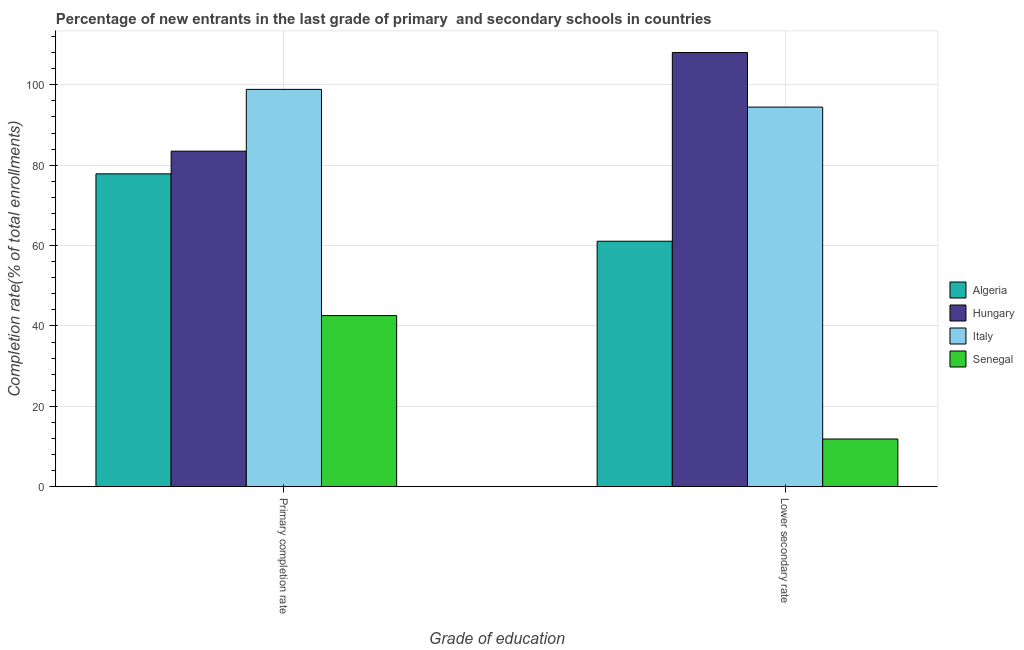How many different coloured bars are there?
Ensure brevity in your answer.  4. Are the number of bars per tick equal to the number of legend labels?
Provide a short and direct response. Yes. What is the label of the 2nd group of bars from the left?
Offer a terse response. Lower secondary rate. What is the completion rate in primary schools in Senegal?
Your response must be concise. 42.58. Across all countries, what is the maximum completion rate in secondary schools?
Your answer should be compact. 108.03. Across all countries, what is the minimum completion rate in primary schools?
Offer a terse response. 42.58. In which country was the completion rate in secondary schools maximum?
Your answer should be very brief. Hungary. In which country was the completion rate in secondary schools minimum?
Your response must be concise. Senegal. What is the total completion rate in primary schools in the graph?
Offer a very short reply. 302.79. What is the difference between the completion rate in secondary schools in Senegal and that in Algeria?
Make the answer very short. -49.21. What is the difference between the completion rate in secondary schools in Senegal and the completion rate in primary schools in Hungary?
Your response must be concise. -71.62. What is the average completion rate in primary schools per country?
Your answer should be very brief. 75.7. What is the difference between the completion rate in primary schools and completion rate in secondary schools in Senegal?
Ensure brevity in your answer.  30.71. What is the ratio of the completion rate in primary schools in Hungary to that in Senegal?
Provide a short and direct response. 1.96. What does the 4th bar from the left in Lower secondary rate represents?
Your answer should be compact. Senegal. What does the 2nd bar from the right in Lower secondary rate represents?
Your response must be concise. Italy. How many bars are there?
Give a very brief answer. 8. Are all the bars in the graph horizontal?
Provide a short and direct response. No. How many countries are there in the graph?
Your response must be concise. 4. What is the difference between two consecutive major ticks on the Y-axis?
Provide a succinct answer. 20. Are the values on the major ticks of Y-axis written in scientific E-notation?
Offer a terse response. No. Does the graph contain grids?
Make the answer very short. Yes. How many legend labels are there?
Your answer should be compact. 4. How are the legend labels stacked?
Ensure brevity in your answer.  Vertical. What is the title of the graph?
Give a very brief answer. Percentage of new entrants in the last grade of primary  and secondary schools in countries. Does "Central African Republic" appear as one of the legend labels in the graph?
Provide a short and direct response. No. What is the label or title of the X-axis?
Make the answer very short. Grade of education. What is the label or title of the Y-axis?
Provide a succinct answer. Completion rate(% of total enrollments). What is the Completion rate(% of total enrollments) of Algeria in Primary completion rate?
Offer a terse response. 77.85. What is the Completion rate(% of total enrollments) in Hungary in Primary completion rate?
Offer a terse response. 83.49. What is the Completion rate(% of total enrollments) of Italy in Primary completion rate?
Make the answer very short. 98.87. What is the Completion rate(% of total enrollments) of Senegal in Primary completion rate?
Your answer should be very brief. 42.58. What is the Completion rate(% of total enrollments) of Algeria in Lower secondary rate?
Offer a terse response. 61.08. What is the Completion rate(% of total enrollments) of Hungary in Lower secondary rate?
Make the answer very short. 108.03. What is the Completion rate(% of total enrollments) of Italy in Lower secondary rate?
Offer a very short reply. 94.46. What is the Completion rate(% of total enrollments) in Senegal in Lower secondary rate?
Make the answer very short. 11.87. Across all Grade of education, what is the maximum Completion rate(% of total enrollments) of Algeria?
Provide a short and direct response. 77.85. Across all Grade of education, what is the maximum Completion rate(% of total enrollments) in Hungary?
Give a very brief answer. 108.03. Across all Grade of education, what is the maximum Completion rate(% of total enrollments) in Italy?
Make the answer very short. 98.87. Across all Grade of education, what is the maximum Completion rate(% of total enrollments) in Senegal?
Give a very brief answer. 42.58. Across all Grade of education, what is the minimum Completion rate(% of total enrollments) in Algeria?
Your answer should be very brief. 61.08. Across all Grade of education, what is the minimum Completion rate(% of total enrollments) of Hungary?
Keep it short and to the point. 83.49. Across all Grade of education, what is the minimum Completion rate(% of total enrollments) of Italy?
Your answer should be very brief. 94.46. Across all Grade of education, what is the minimum Completion rate(% of total enrollments) in Senegal?
Offer a very short reply. 11.87. What is the total Completion rate(% of total enrollments) of Algeria in the graph?
Your answer should be very brief. 138.93. What is the total Completion rate(% of total enrollments) in Hungary in the graph?
Give a very brief answer. 191.53. What is the total Completion rate(% of total enrollments) of Italy in the graph?
Your response must be concise. 193.32. What is the total Completion rate(% of total enrollments) in Senegal in the graph?
Ensure brevity in your answer.  54.46. What is the difference between the Completion rate(% of total enrollments) of Algeria in Primary completion rate and that in Lower secondary rate?
Ensure brevity in your answer.  16.76. What is the difference between the Completion rate(% of total enrollments) of Hungary in Primary completion rate and that in Lower secondary rate?
Ensure brevity in your answer.  -24.54. What is the difference between the Completion rate(% of total enrollments) of Italy in Primary completion rate and that in Lower secondary rate?
Offer a very short reply. 4.41. What is the difference between the Completion rate(% of total enrollments) of Senegal in Primary completion rate and that in Lower secondary rate?
Make the answer very short. 30.71. What is the difference between the Completion rate(% of total enrollments) of Algeria in Primary completion rate and the Completion rate(% of total enrollments) of Hungary in Lower secondary rate?
Offer a terse response. -30.19. What is the difference between the Completion rate(% of total enrollments) of Algeria in Primary completion rate and the Completion rate(% of total enrollments) of Italy in Lower secondary rate?
Provide a succinct answer. -16.61. What is the difference between the Completion rate(% of total enrollments) of Algeria in Primary completion rate and the Completion rate(% of total enrollments) of Senegal in Lower secondary rate?
Provide a succinct answer. 65.97. What is the difference between the Completion rate(% of total enrollments) in Hungary in Primary completion rate and the Completion rate(% of total enrollments) in Italy in Lower secondary rate?
Your answer should be compact. -10.97. What is the difference between the Completion rate(% of total enrollments) in Hungary in Primary completion rate and the Completion rate(% of total enrollments) in Senegal in Lower secondary rate?
Provide a succinct answer. 71.62. What is the difference between the Completion rate(% of total enrollments) of Italy in Primary completion rate and the Completion rate(% of total enrollments) of Senegal in Lower secondary rate?
Offer a terse response. 86.99. What is the average Completion rate(% of total enrollments) of Algeria per Grade of education?
Ensure brevity in your answer.  69.47. What is the average Completion rate(% of total enrollments) in Hungary per Grade of education?
Ensure brevity in your answer.  95.76. What is the average Completion rate(% of total enrollments) of Italy per Grade of education?
Make the answer very short. 96.66. What is the average Completion rate(% of total enrollments) in Senegal per Grade of education?
Offer a terse response. 27.23. What is the difference between the Completion rate(% of total enrollments) in Algeria and Completion rate(% of total enrollments) in Hungary in Primary completion rate?
Your answer should be very brief. -5.64. What is the difference between the Completion rate(% of total enrollments) of Algeria and Completion rate(% of total enrollments) of Italy in Primary completion rate?
Ensure brevity in your answer.  -21.02. What is the difference between the Completion rate(% of total enrollments) in Algeria and Completion rate(% of total enrollments) in Senegal in Primary completion rate?
Offer a very short reply. 35.27. What is the difference between the Completion rate(% of total enrollments) in Hungary and Completion rate(% of total enrollments) in Italy in Primary completion rate?
Keep it short and to the point. -15.37. What is the difference between the Completion rate(% of total enrollments) in Hungary and Completion rate(% of total enrollments) in Senegal in Primary completion rate?
Give a very brief answer. 40.91. What is the difference between the Completion rate(% of total enrollments) in Italy and Completion rate(% of total enrollments) in Senegal in Primary completion rate?
Give a very brief answer. 56.28. What is the difference between the Completion rate(% of total enrollments) of Algeria and Completion rate(% of total enrollments) of Hungary in Lower secondary rate?
Offer a very short reply. -46.95. What is the difference between the Completion rate(% of total enrollments) of Algeria and Completion rate(% of total enrollments) of Italy in Lower secondary rate?
Offer a terse response. -33.37. What is the difference between the Completion rate(% of total enrollments) of Algeria and Completion rate(% of total enrollments) of Senegal in Lower secondary rate?
Ensure brevity in your answer.  49.21. What is the difference between the Completion rate(% of total enrollments) of Hungary and Completion rate(% of total enrollments) of Italy in Lower secondary rate?
Keep it short and to the point. 13.58. What is the difference between the Completion rate(% of total enrollments) of Hungary and Completion rate(% of total enrollments) of Senegal in Lower secondary rate?
Offer a very short reply. 96.16. What is the difference between the Completion rate(% of total enrollments) of Italy and Completion rate(% of total enrollments) of Senegal in Lower secondary rate?
Your answer should be very brief. 82.58. What is the ratio of the Completion rate(% of total enrollments) of Algeria in Primary completion rate to that in Lower secondary rate?
Your response must be concise. 1.27. What is the ratio of the Completion rate(% of total enrollments) in Hungary in Primary completion rate to that in Lower secondary rate?
Offer a terse response. 0.77. What is the ratio of the Completion rate(% of total enrollments) of Italy in Primary completion rate to that in Lower secondary rate?
Offer a terse response. 1.05. What is the ratio of the Completion rate(% of total enrollments) in Senegal in Primary completion rate to that in Lower secondary rate?
Keep it short and to the point. 3.59. What is the difference between the highest and the second highest Completion rate(% of total enrollments) of Algeria?
Give a very brief answer. 16.76. What is the difference between the highest and the second highest Completion rate(% of total enrollments) of Hungary?
Ensure brevity in your answer.  24.54. What is the difference between the highest and the second highest Completion rate(% of total enrollments) in Italy?
Keep it short and to the point. 4.41. What is the difference between the highest and the second highest Completion rate(% of total enrollments) in Senegal?
Ensure brevity in your answer.  30.71. What is the difference between the highest and the lowest Completion rate(% of total enrollments) in Algeria?
Provide a short and direct response. 16.76. What is the difference between the highest and the lowest Completion rate(% of total enrollments) of Hungary?
Make the answer very short. 24.54. What is the difference between the highest and the lowest Completion rate(% of total enrollments) of Italy?
Your response must be concise. 4.41. What is the difference between the highest and the lowest Completion rate(% of total enrollments) in Senegal?
Keep it short and to the point. 30.71. 